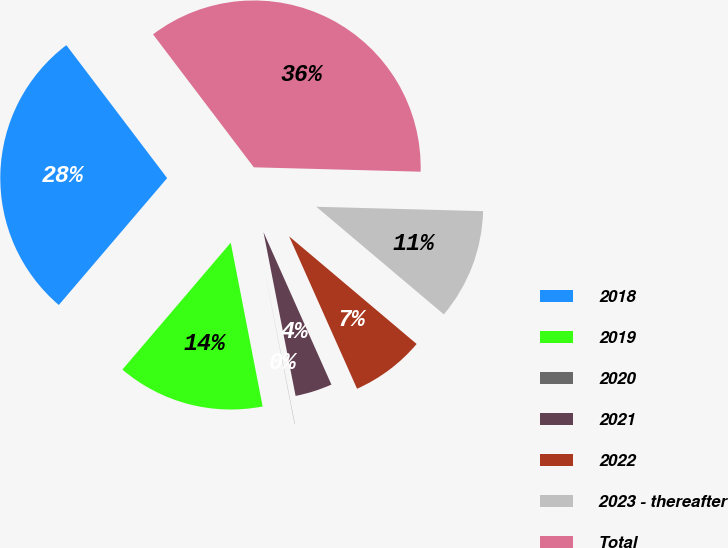Convert chart to OTSL. <chart><loc_0><loc_0><loc_500><loc_500><pie_chart><fcel>2018<fcel>2019<fcel>2020<fcel>2021<fcel>2022<fcel>2023 - thereafter<fcel>Total<nl><fcel>28.43%<fcel>14.31%<fcel>0.02%<fcel>3.59%<fcel>7.17%<fcel>10.74%<fcel>35.74%<nl></chart> 